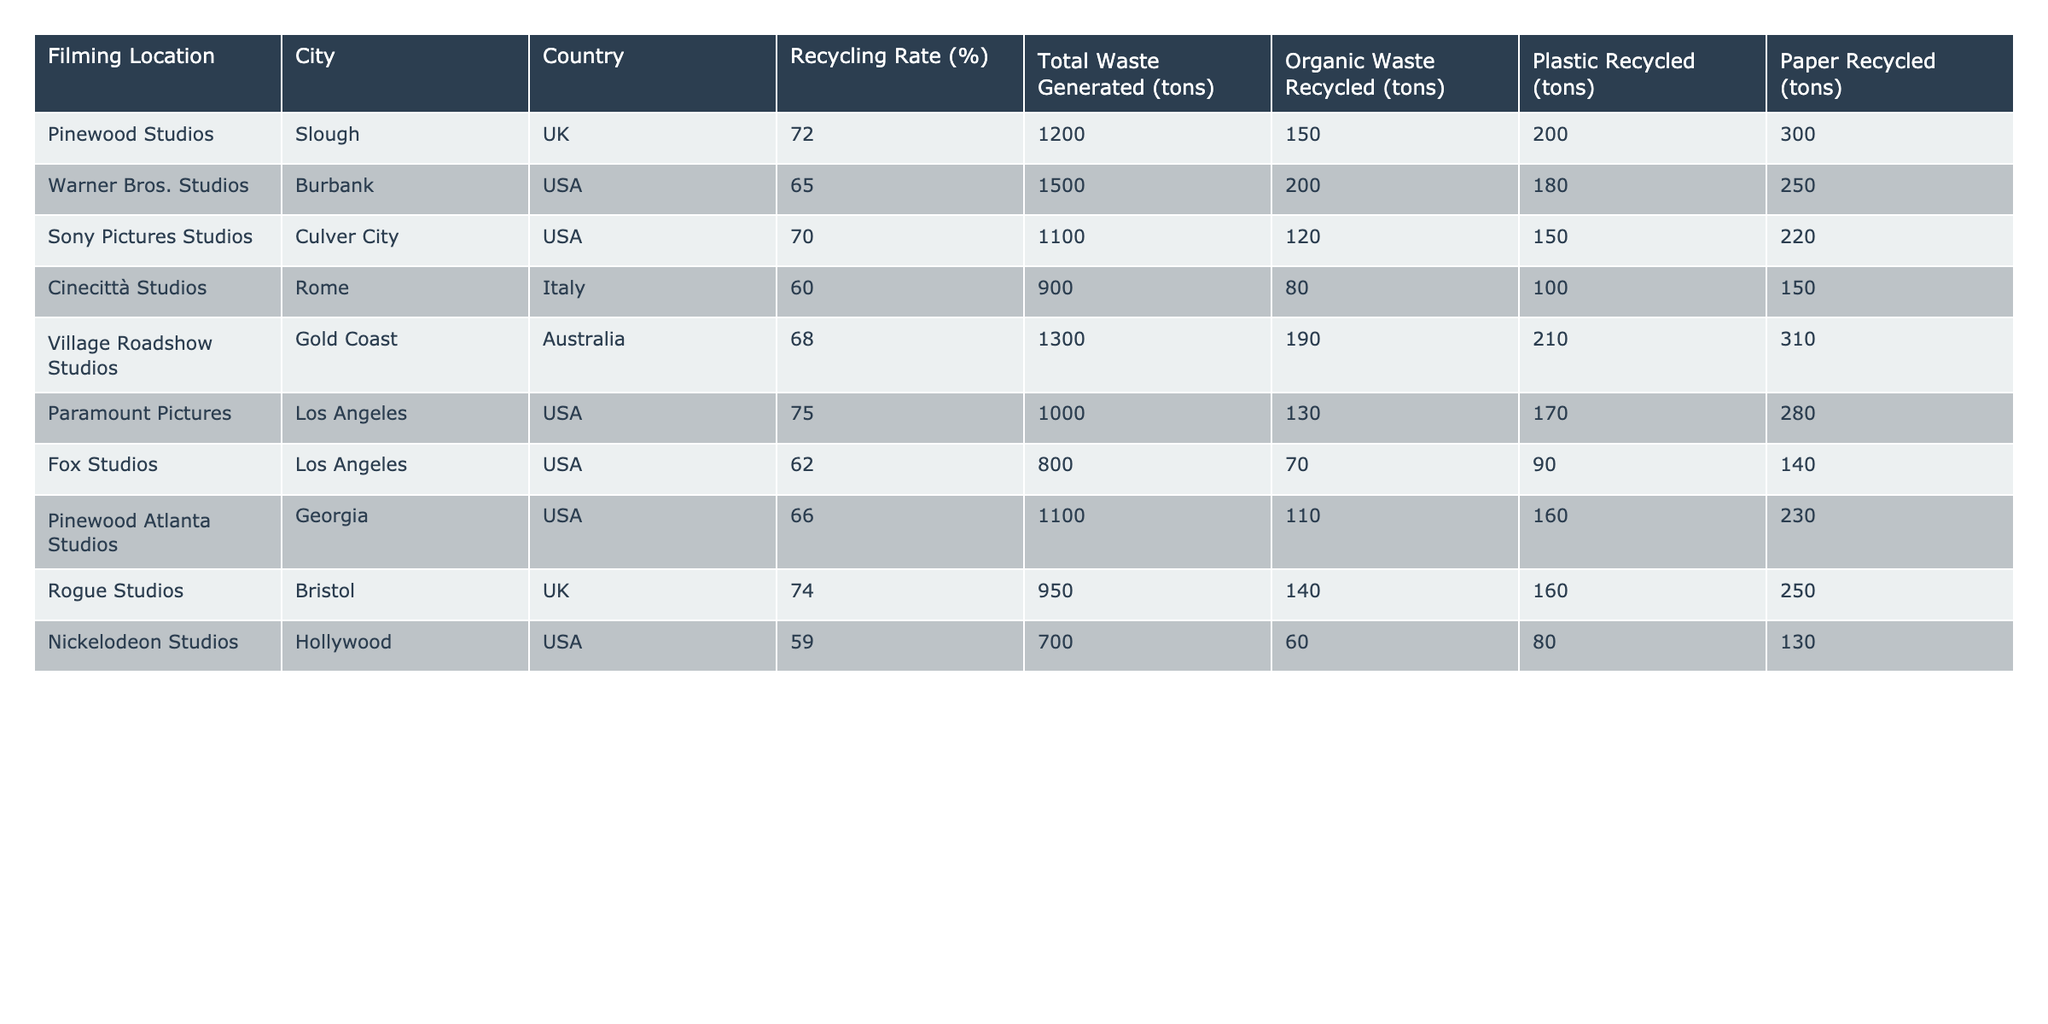What is the recycling rate for Pinewood Studios? The recycling rate is provided directly in the table next to Pinewood Studios, which shows a rate of 72%.
Answer: 72% Which location has the highest recycling rate? To find the highest recycling rate, we compare all the values in the "Recycling Rate (%)" column. Paramount Pictures has the highest at 75%.
Answer: 75% How much organic waste was recycled at Warner Bros. Studios? The table shows that Warner Bros. Studios recycled 200 tons of organic waste, as indicated in the "Organic Waste Recycled (tons)" column.
Answer: 200 tons What is the total waste generated by Sony Pictures Studios? The total waste generated can be found in the "Total Waste Generated (tons)" column for Sony Pictures Studios, which is 1100 tons.
Answer: 1100 tons Is the recycling rate for Nickelodeon Studios above or below 60%? The recycling rate for Nickelodeon Studios is 59%, which is below 60%.
Answer: Below 60% What is the average recycling rate for all listed studios? To calculate the average, add all recycling rates together: (72 + 65 + 70 + 60 + 68 + 75 + 62 + 66 + 74 + 59) = 699. Then divide by the number of studios (10): 699/10 = 69.9%.
Answer: 69.9% How much plastic waste was recycled at Village Roadshow Studios? The table indicates that Village Roadshow Studios recycled 210 tons of plastic waste, based on the data in the respective column.
Answer: 210 tons Which studio recycled the least amount of organic waste? By looking at the "Organic Waste Recycled (tons)" column, we find that Nickelodeon Studios recycled the least amount, which is 60 tons.
Answer: 60 tons If we combine the organic and plastic waste recycled at Paramount Pictures, how much is that? For Paramount Pictures, organic waste recycled is 130 tons and plastic waste recycled is 170 tons. Adding these gives us 130 + 170 = 300 tons in total.
Answer: 300 tons Which country has the lowest recycling rate among the listed studios? By comparing all the recycling rates in the table, we see that Cinecittà Studios in Italy has the lowest rate at 60%.
Answer: Italy 60% 